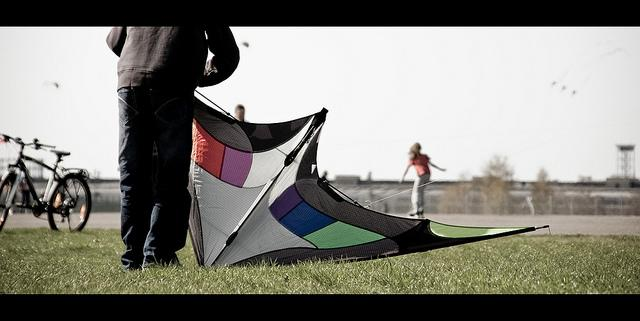How did the kite flyer get to the park?

Choices:
A) bus
B) bicycle
C) car
D) wagon bicycle 